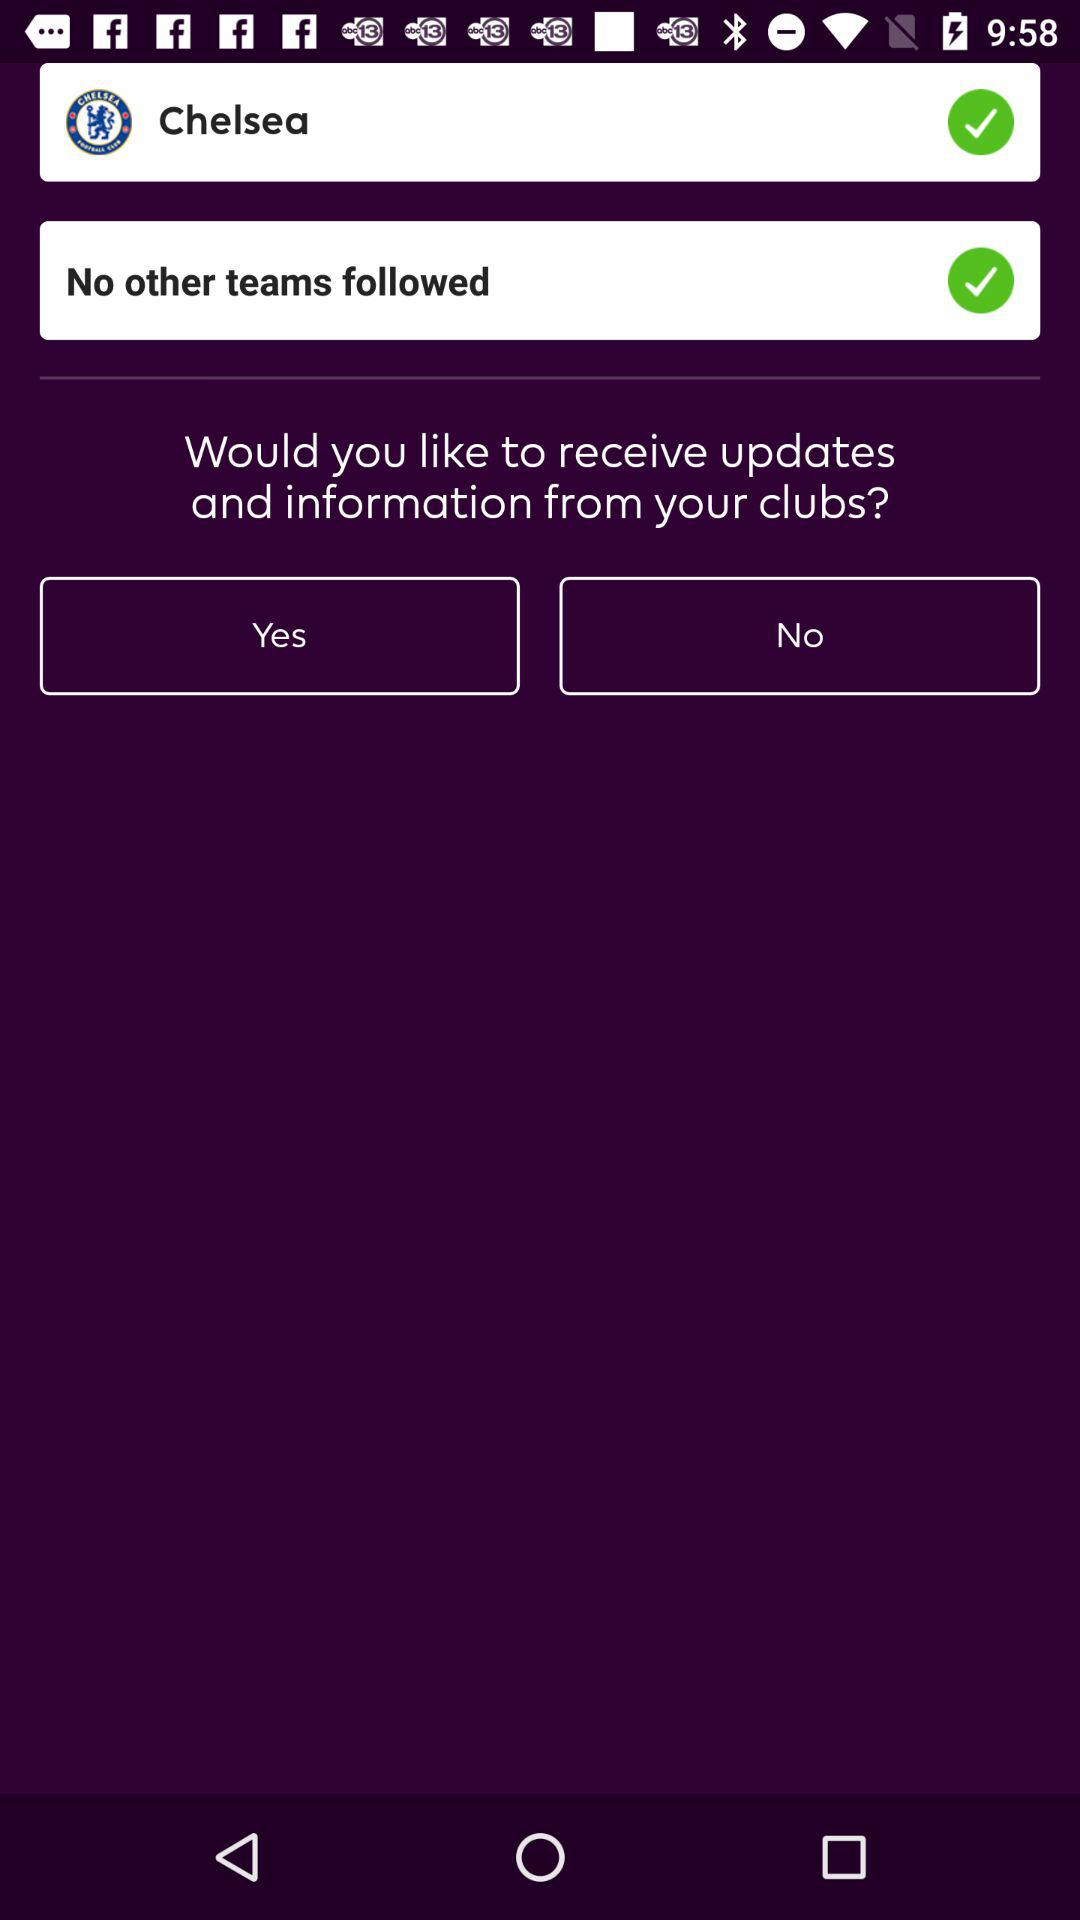Is "Chelsea" selected or not?
Answer the question using a single word or phrase. "Chelsea" is selected. 